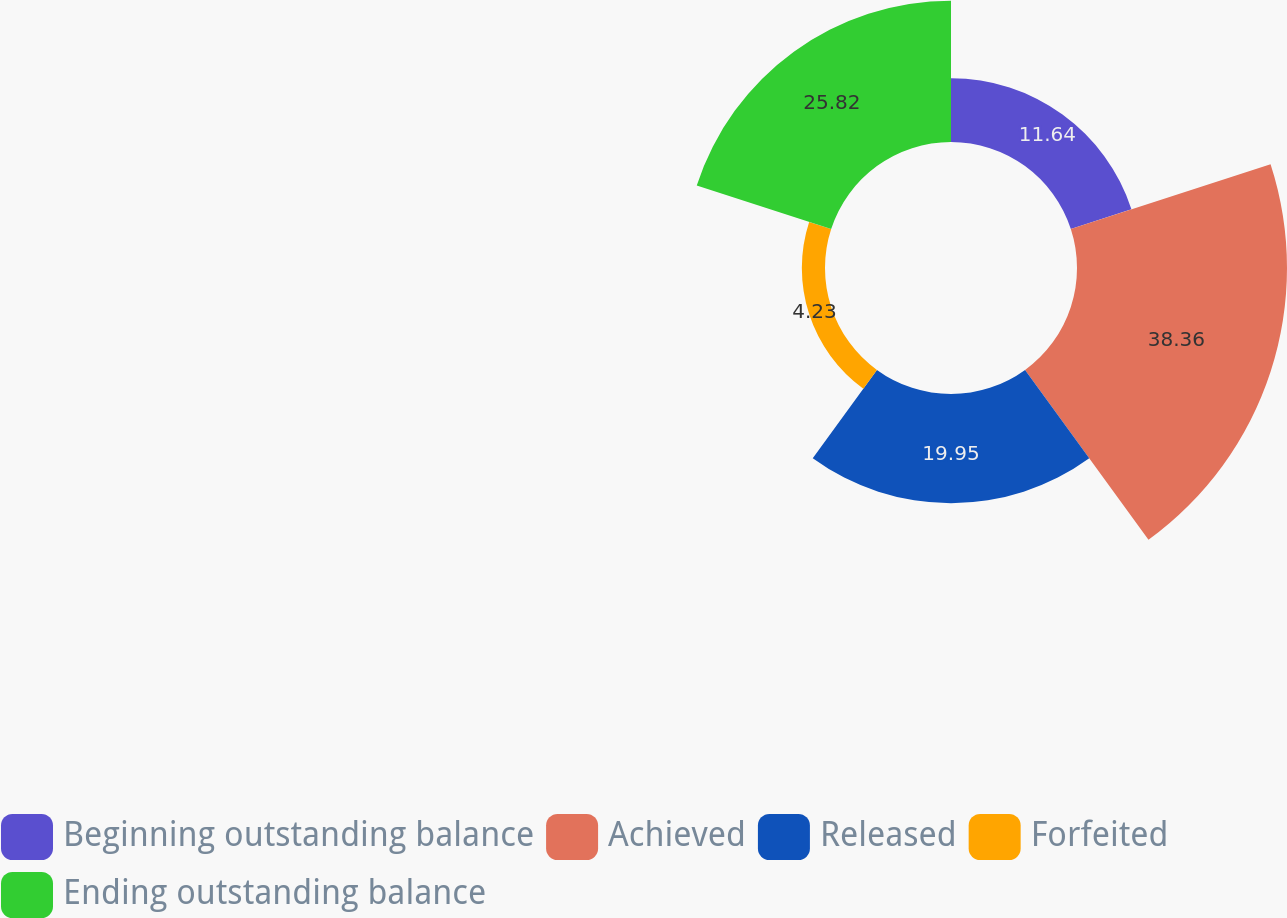Convert chart to OTSL. <chart><loc_0><loc_0><loc_500><loc_500><pie_chart><fcel>Beginning outstanding balance<fcel>Achieved<fcel>Released<fcel>Forfeited<fcel>Ending outstanding balance<nl><fcel>11.64%<fcel>38.36%<fcel>19.95%<fcel>4.23%<fcel>25.82%<nl></chart> 